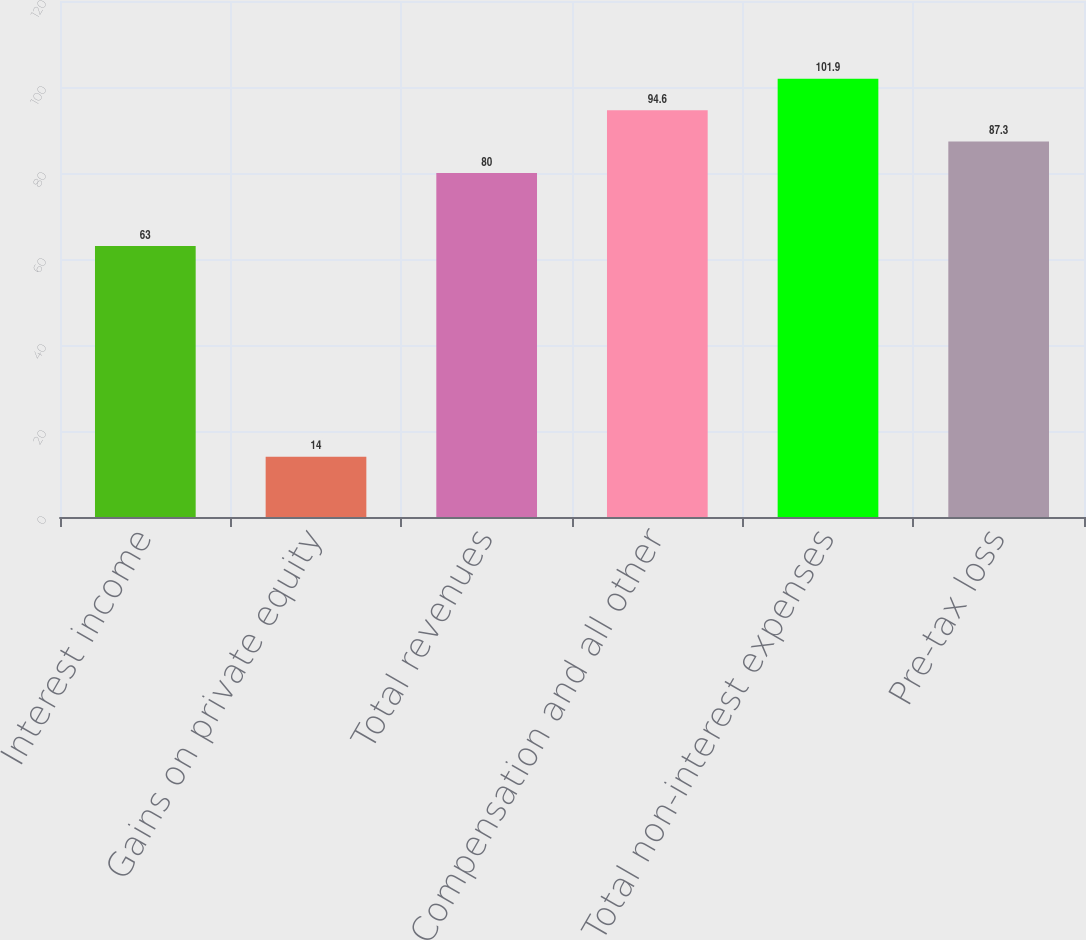Convert chart to OTSL. <chart><loc_0><loc_0><loc_500><loc_500><bar_chart><fcel>Interest income<fcel>Gains on private equity<fcel>Total revenues<fcel>Compensation and all other<fcel>Total non-interest expenses<fcel>Pre-tax loss<nl><fcel>63<fcel>14<fcel>80<fcel>94.6<fcel>101.9<fcel>87.3<nl></chart> 